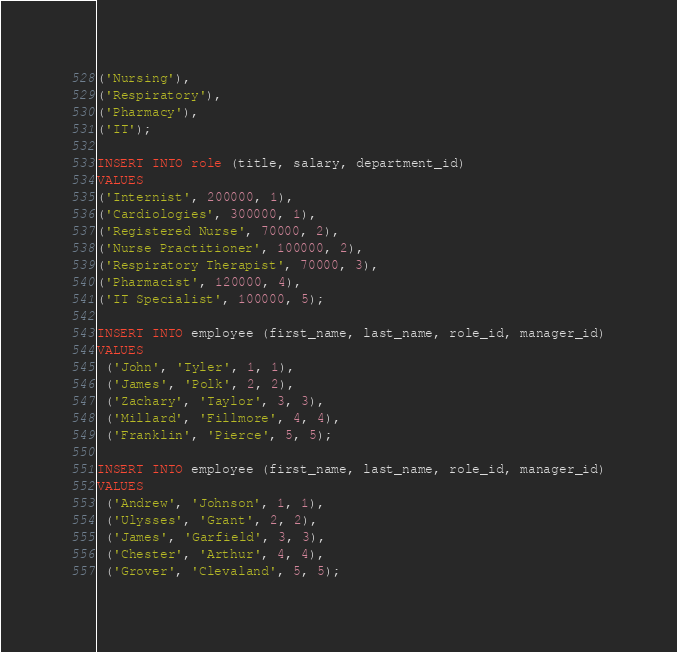<code> <loc_0><loc_0><loc_500><loc_500><_SQL_>('Nursing'),
('Respiratory'),
('Pharmacy'),
('IT');

INSERT INTO role (title, salary, department_id)
VALUES
('Internist', 200000, 1),
('Cardiologies', 300000, 1),
('Registered Nurse', 70000, 2),
('Nurse Practitioner', 100000, 2),
('Respiratory Therapist', 70000, 3),
('Pharmacist', 120000, 4),
('IT Specialist', 100000, 5);

INSERT INTO employee (first_name, last_name, role_id, manager_id)
VALUES
 ('John', 'Tyler', 1, 1),
 ('James', 'Polk', 2, 2),
 ('Zachary', 'Taylor', 3, 3),
 ('Millard', 'Fillmore', 4, 4),
 ('Franklin', 'Pierce', 5, 5);

INSERT INTO employee (first_name, last_name, role_id, manager_id)
VALUES
 ('Andrew', 'Johnson', 1, 1),
 ('Ulysses', 'Grant', 2, 2),
 ('James', 'Garfield', 3, 3),
 ('Chester', 'Arthur', 4, 4),
 ('Grover', 'Clevaland', 5, 5);</code> 